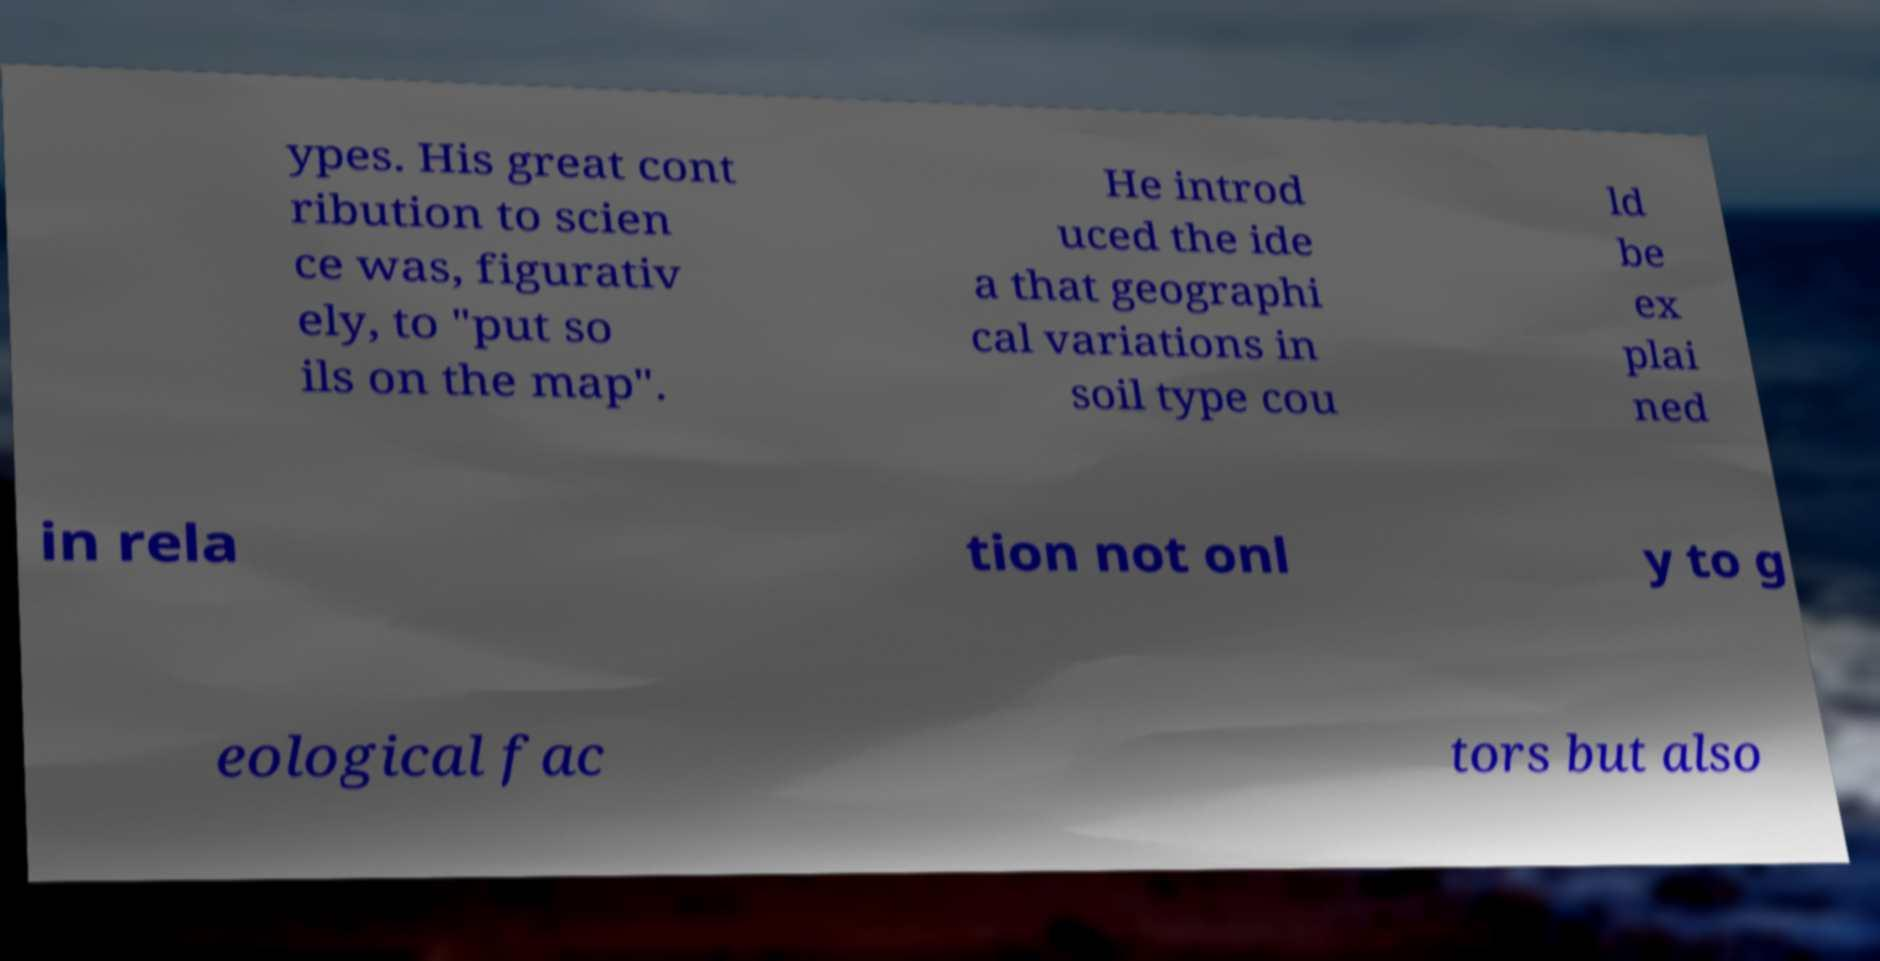Please read and relay the text visible in this image. What does it say? ypes. His great cont ribution to scien ce was, figurativ ely, to "put so ils on the map". He introd uced the ide a that geographi cal variations in soil type cou ld be ex plai ned in rela tion not onl y to g eological fac tors but also 